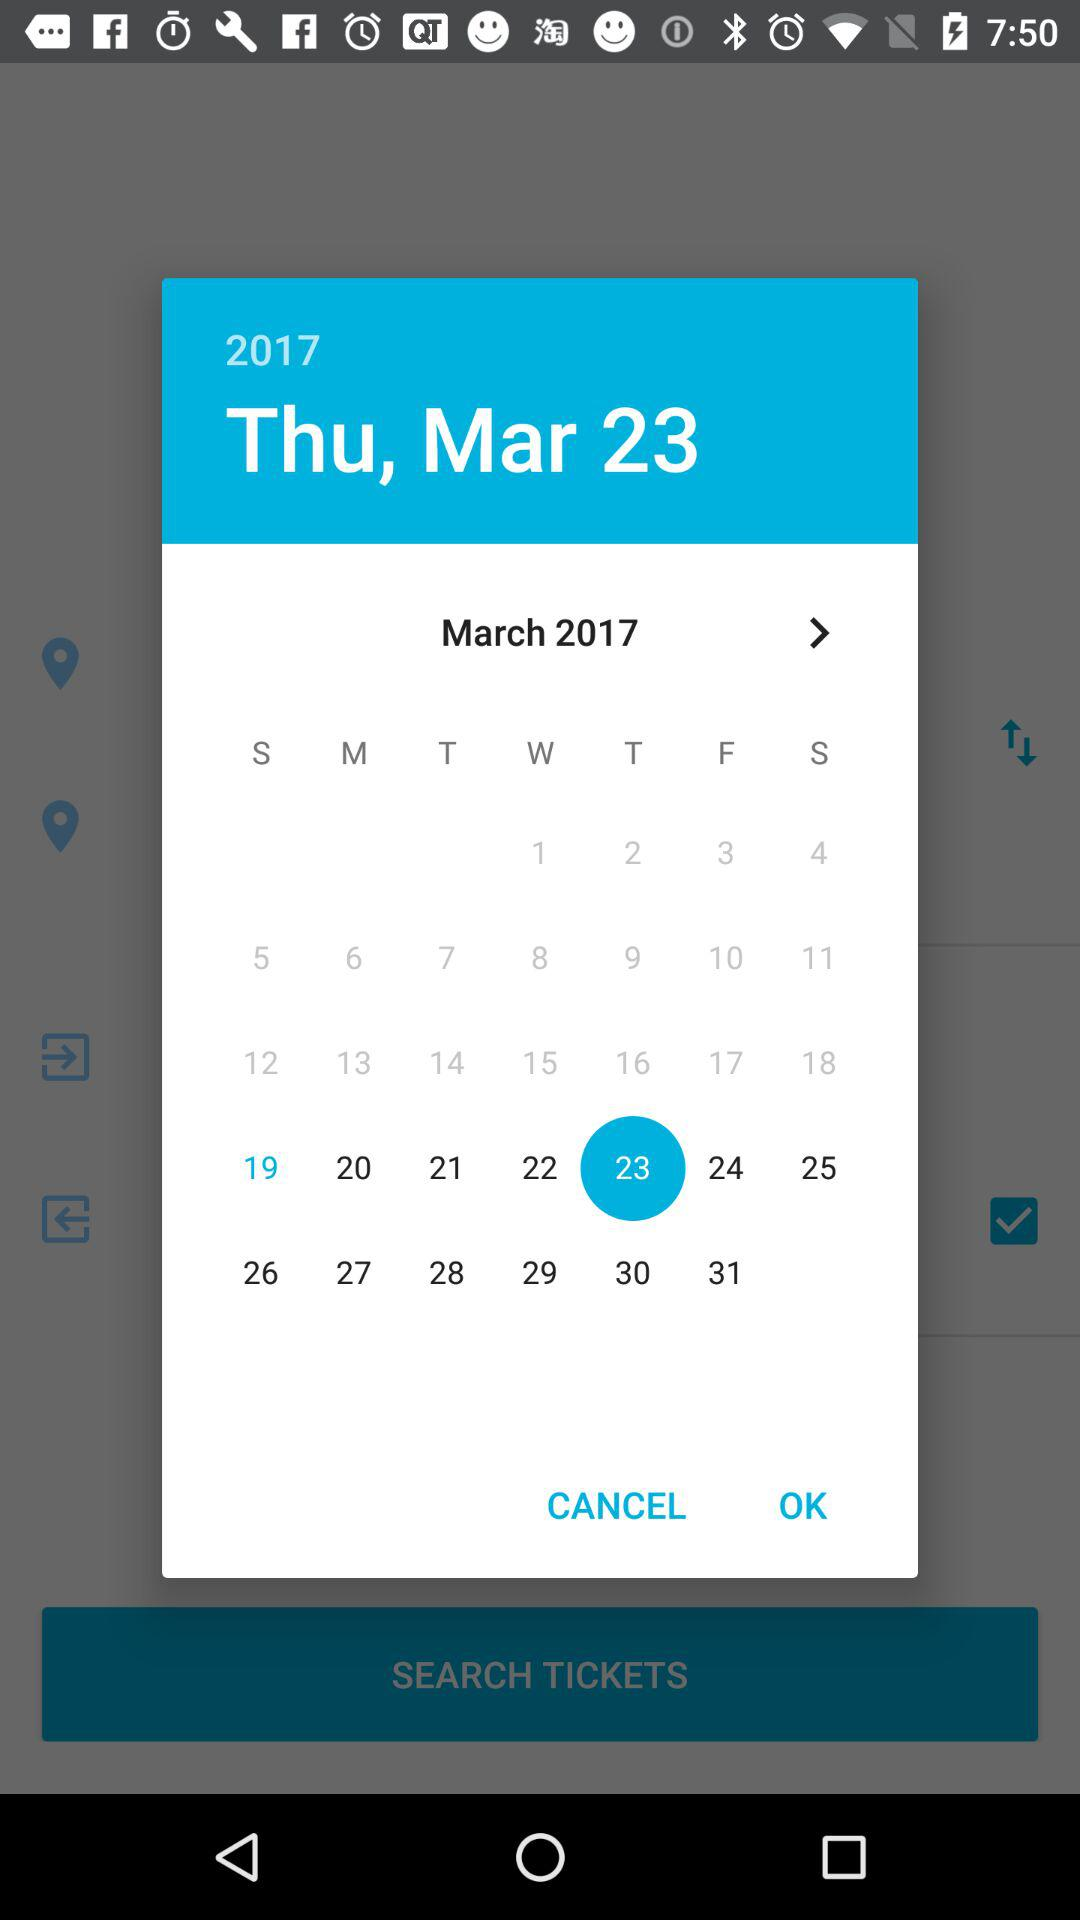Which date is selected? The selected date is Thursday, March 23, 2017. 